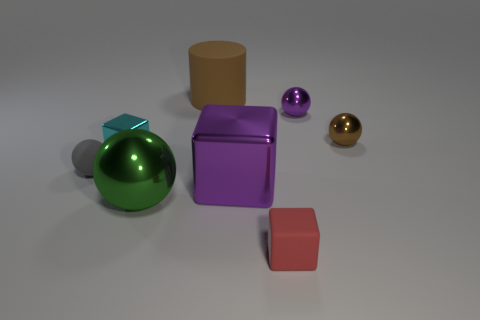Subtract all tiny matte balls. How many balls are left? 3 Subtract all green spheres. How many spheres are left? 3 Subtract all yellow balls. Subtract all yellow cylinders. How many balls are left? 4 Add 1 tiny red shiny cylinders. How many objects exist? 9 Subtract all cubes. How many objects are left? 5 Add 1 cyan things. How many cyan things are left? 2 Add 4 purple balls. How many purple balls exist? 5 Subtract 0 gray blocks. How many objects are left? 8 Subtract all purple metal things. Subtract all red objects. How many objects are left? 5 